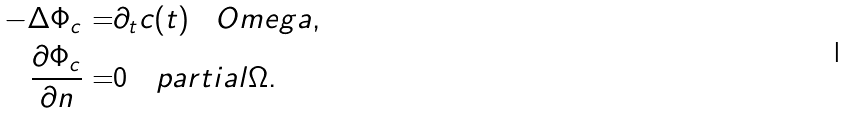Convert formula to latex. <formula><loc_0><loc_0><loc_500><loc_500>- \Delta \Phi _ { c } = & \partial _ { t } c ( t ) \quad O m e g a , \\ \frac { \partial \Phi _ { c } } { \partial n } = & 0 \quad p a r t i a l \Omega .</formula> 